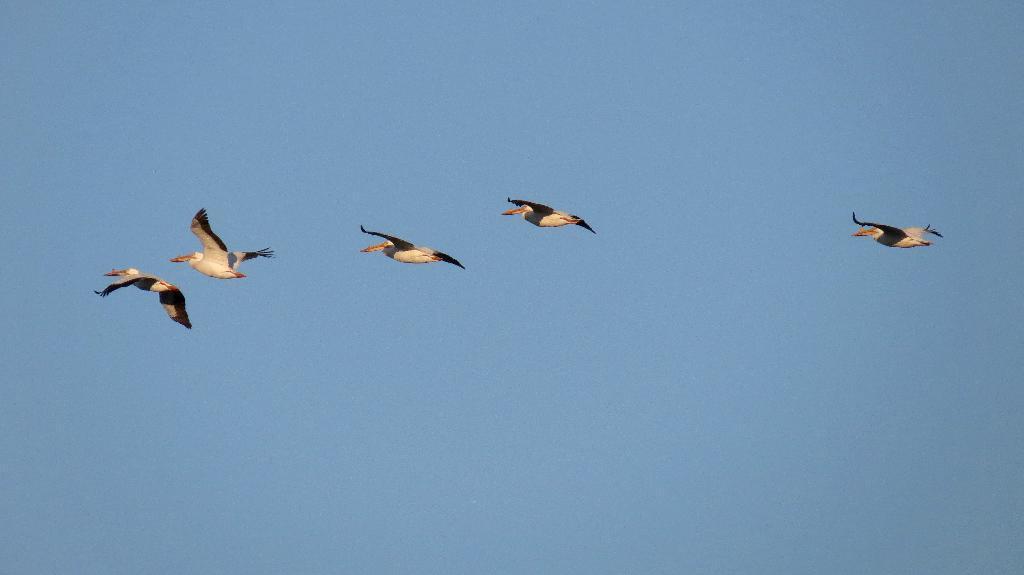Describe this image in one or two sentences. In this image there are five birds flying in the sky. 